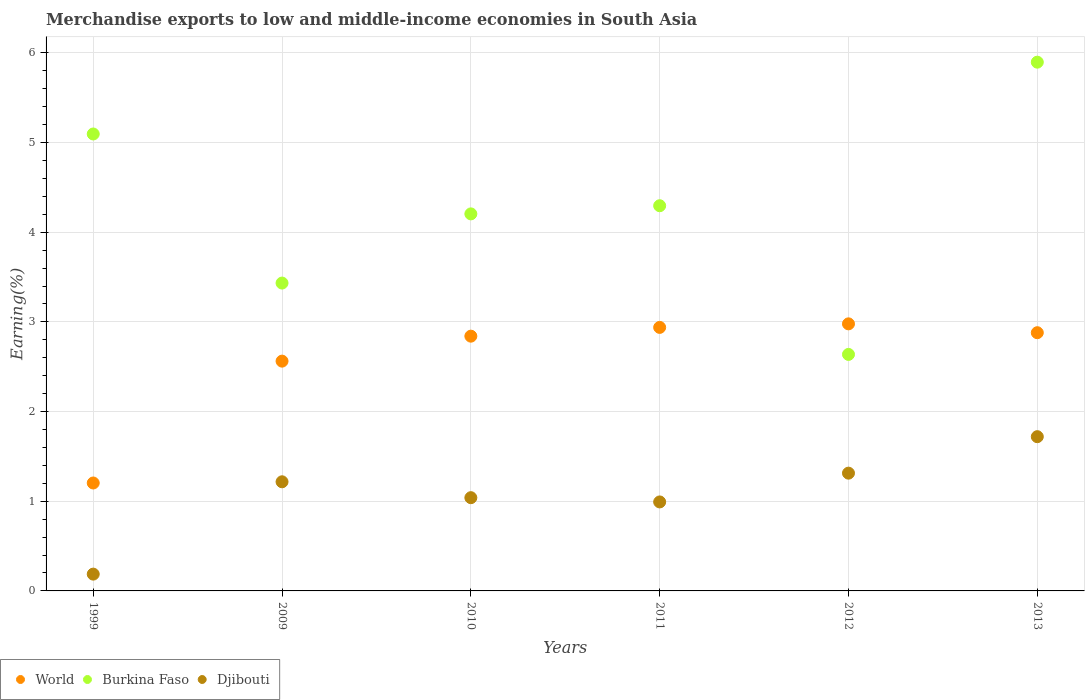How many different coloured dotlines are there?
Offer a very short reply. 3. Is the number of dotlines equal to the number of legend labels?
Give a very brief answer. Yes. What is the percentage of amount earned from merchandise exports in Djibouti in 2011?
Offer a very short reply. 0.99. Across all years, what is the maximum percentage of amount earned from merchandise exports in Burkina Faso?
Make the answer very short. 5.9. Across all years, what is the minimum percentage of amount earned from merchandise exports in World?
Offer a terse response. 1.2. What is the total percentage of amount earned from merchandise exports in Burkina Faso in the graph?
Keep it short and to the point. 25.56. What is the difference between the percentage of amount earned from merchandise exports in Burkina Faso in 2010 and that in 2012?
Your response must be concise. 1.57. What is the difference between the percentage of amount earned from merchandise exports in Djibouti in 2010 and the percentage of amount earned from merchandise exports in Burkina Faso in 2012?
Ensure brevity in your answer.  -1.6. What is the average percentage of amount earned from merchandise exports in World per year?
Your response must be concise. 2.57. In the year 2009, what is the difference between the percentage of amount earned from merchandise exports in World and percentage of amount earned from merchandise exports in Burkina Faso?
Your response must be concise. -0.87. What is the ratio of the percentage of amount earned from merchandise exports in World in 2011 to that in 2013?
Make the answer very short. 1.02. Is the percentage of amount earned from merchandise exports in Djibouti in 2011 less than that in 2013?
Your answer should be very brief. Yes. What is the difference between the highest and the second highest percentage of amount earned from merchandise exports in Djibouti?
Your answer should be compact. 0.41. What is the difference between the highest and the lowest percentage of amount earned from merchandise exports in Djibouti?
Offer a very short reply. 1.53. In how many years, is the percentage of amount earned from merchandise exports in Burkina Faso greater than the average percentage of amount earned from merchandise exports in Burkina Faso taken over all years?
Give a very brief answer. 3. Is the sum of the percentage of amount earned from merchandise exports in World in 1999 and 2009 greater than the maximum percentage of amount earned from merchandise exports in Burkina Faso across all years?
Give a very brief answer. No. Is it the case that in every year, the sum of the percentage of amount earned from merchandise exports in Djibouti and percentage of amount earned from merchandise exports in Burkina Faso  is greater than the percentage of amount earned from merchandise exports in World?
Give a very brief answer. Yes. Is the percentage of amount earned from merchandise exports in World strictly greater than the percentage of amount earned from merchandise exports in Burkina Faso over the years?
Your response must be concise. No. How many dotlines are there?
Make the answer very short. 3. How many years are there in the graph?
Your answer should be compact. 6. Are the values on the major ticks of Y-axis written in scientific E-notation?
Offer a very short reply. No. Does the graph contain any zero values?
Make the answer very short. No. Does the graph contain grids?
Keep it short and to the point. Yes. What is the title of the graph?
Your answer should be very brief. Merchandise exports to low and middle-income economies in South Asia. What is the label or title of the X-axis?
Offer a terse response. Years. What is the label or title of the Y-axis?
Your response must be concise. Earning(%). What is the Earning(%) of World in 1999?
Give a very brief answer. 1.2. What is the Earning(%) of Burkina Faso in 1999?
Your answer should be compact. 5.1. What is the Earning(%) of Djibouti in 1999?
Offer a terse response. 0.19. What is the Earning(%) in World in 2009?
Ensure brevity in your answer.  2.56. What is the Earning(%) in Burkina Faso in 2009?
Ensure brevity in your answer.  3.43. What is the Earning(%) in Djibouti in 2009?
Ensure brevity in your answer.  1.22. What is the Earning(%) in World in 2010?
Make the answer very short. 2.84. What is the Earning(%) of Burkina Faso in 2010?
Provide a short and direct response. 4.2. What is the Earning(%) in Djibouti in 2010?
Ensure brevity in your answer.  1.04. What is the Earning(%) of World in 2011?
Your response must be concise. 2.94. What is the Earning(%) in Burkina Faso in 2011?
Your response must be concise. 4.3. What is the Earning(%) of Djibouti in 2011?
Offer a very short reply. 0.99. What is the Earning(%) in World in 2012?
Make the answer very short. 2.98. What is the Earning(%) in Burkina Faso in 2012?
Offer a terse response. 2.64. What is the Earning(%) in Djibouti in 2012?
Provide a short and direct response. 1.31. What is the Earning(%) in World in 2013?
Provide a short and direct response. 2.88. What is the Earning(%) in Burkina Faso in 2013?
Give a very brief answer. 5.9. What is the Earning(%) of Djibouti in 2013?
Your response must be concise. 1.72. Across all years, what is the maximum Earning(%) of World?
Make the answer very short. 2.98. Across all years, what is the maximum Earning(%) in Burkina Faso?
Provide a short and direct response. 5.9. Across all years, what is the maximum Earning(%) of Djibouti?
Your response must be concise. 1.72. Across all years, what is the minimum Earning(%) of World?
Ensure brevity in your answer.  1.2. Across all years, what is the minimum Earning(%) of Burkina Faso?
Keep it short and to the point. 2.64. Across all years, what is the minimum Earning(%) in Djibouti?
Provide a short and direct response. 0.19. What is the total Earning(%) in World in the graph?
Ensure brevity in your answer.  15.4. What is the total Earning(%) of Burkina Faso in the graph?
Ensure brevity in your answer.  25.56. What is the total Earning(%) of Djibouti in the graph?
Make the answer very short. 6.47. What is the difference between the Earning(%) of World in 1999 and that in 2009?
Keep it short and to the point. -1.36. What is the difference between the Earning(%) in Burkina Faso in 1999 and that in 2009?
Your answer should be very brief. 1.66. What is the difference between the Earning(%) in Djibouti in 1999 and that in 2009?
Give a very brief answer. -1.03. What is the difference between the Earning(%) in World in 1999 and that in 2010?
Provide a short and direct response. -1.64. What is the difference between the Earning(%) in Burkina Faso in 1999 and that in 2010?
Your answer should be very brief. 0.89. What is the difference between the Earning(%) of Djibouti in 1999 and that in 2010?
Offer a terse response. -0.85. What is the difference between the Earning(%) of World in 1999 and that in 2011?
Provide a succinct answer. -1.74. What is the difference between the Earning(%) of Burkina Faso in 1999 and that in 2011?
Your response must be concise. 0.8. What is the difference between the Earning(%) in Djibouti in 1999 and that in 2011?
Make the answer very short. -0.81. What is the difference between the Earning(%) in World in 1999 and that in 2012?
Offer a terse response. -1.77. What is the difference between the Earning(%) in Burkina Faso in 1999 and that in 2012?
Offer a very short reply. 2.46. What is the difference between the Earning(%) of Djibouti in 1999 and that in 2012?
Provide a succinct answer. -1.13. What is the difference between the Earning(%) in World in 1999 and that in 2013?
Your answer should be compact. -1.68. What is the difference between the Earning(%) in Burkina Faso in 1999 and that in 2013?
Your response must be concise. -0.8. What is the difference between the Earning(%) in Djibouti in 1999 and that in 2013?
Keep it short and to the point. -1.53. What is the difference between the Earning(%) in World in 2009 and that in 2010?
Your answer should be compact. -0.28. What is the difference between the Earning(%) of Burkina Faso in 2009 and that in 2010?
Offer a very short reply. -0.77. What is the difference between the Earning(%) in Djibouti in 2009 and that in 2010?
Your response must be concise. 0.18. What is the difference between the Earning(%) in World in 2009 and that in 2011?
Your answer should be compact. -0.38. What is the difference between the Earning(%) of Burkina Faso in 2009 and that in 2011?
Your answer should be very brief. -0.86. What is the difference between the Earning(%) in Djibouti in 2009 and that in 2011?
Provide a short and direct response. 0.22. What is the difference between the Earning(%) of World in 2009 and that in 2012?
Ensure brevity in your answer.  -0.42. What is the difference between the Earning(%) of Burkina Faso in 2009 and that in 2012?
Provide a short and direct response. 0.8. What is the difference between the Earning(%) in Djibouti in 2009 and that in 2012?
Keep it short and to the point. -0.1. What is the difference between the Earning(%) in World in 2009 and that in 2013?
Make the answer very short. -0.32. What is the difference between the Earning(%) of Burkina Faso in 2009 and that in 2013?
Your answer should be compact. -2.46. What is the difference between the Earning(%) in Djibouti in 2009 and that in 2013?
Make the answer very short. -0.5. What is the difference between the Earning(%) of World in 2010 and that in 2011?
Make the answer very short. -0.1. What is the difference between the Earning(%) in Burkina Faso in 2010 and that in 2011?
Offer a very short reply. -0.09. What is the difference between the Earning(%) of Djibouti in 2010 and that in 2011?
Offer a terse response. 0.05. What is the difference between the Earning(%) in World in 2010 and that in 2012?
Keep it short and to the point. -0.14. What is the difference between the Earning(%) in Burkina Faso in 2010 and that in 2012?
Your response must be concise. 1.57. What is the difference between the Earning(%) of Djibouti in 2010 and that in 2012?
Give a very brief answer. -0.27. What is the difference between the Earning(%) in World in 2010 and that in 2013?
Offer a terse response. -0.04. What is the difference between the Earning(%) in Burkina Faso in 2010 and that in 2013?
Make the answer very short. -1.69. What is the difference between the Earning(%) in Djibouti in 2010 and that in 2013?
Offer a terse response. -0.68. What is the difference between the Earning(%) of World in 2011 and that in 2012?
Make the answer very short. -0.04. What is the difference between the Earning(%) of Burkina Faso in 2011 and that in 2012?
Offer a terse response. 1.66. What is the difference between the Earning(%) in Djibouti in 2011 and that in 2012?
Offer a very short reply. -0.32. What is the difference between the Earning(%) of World in 2011 and that in 2013?
Offer a terse response. 0.06. What is the difference between the Earning(%) in Burkina Faso in 2011 and that in 2013?
Your response must be concise. -1.6. What is the difference between the Earning(%) of Djibouti in 2011 and that in 2013?
Ensure brevity in your answer.  -0.73. What is the difference between the Earning(%) of World in 2012 and that in 2013?
Give a very brief answer. 0.1. What is the difference between the Earning(%) in Burkina Faso in 2012 and that in 2013?
Keep it short and to the point. -3.26. What is the difference between the Earning(%) of Djibouti in 2012 and that in 2013?
Your answer should be compact. -0.41. What is the difference between the Earning(%) of World in 1999 and the Earning(%) of Burkina Faso in 2009?
Make the answer very short. -2.23. What is the difference between the Earning(%) in World in 1999 and the Earning(%) in Djibouti in 2009?
Your answer should be very brief. -0.01. What is the difference between the Earning(%) in Burkina Faso in 1999 and the Earning(%) in Djibouti in 2009?
Give a very brief answer. 3.88. What is the difference between the Earning(%) of World in 1999 and the Earning(%) of Burkina Faso in 2010?
Provide a short and direct response. -3. What is the difference between the Earning(%) of World in 1999 and the Earning(%) of Djibouti in 2010?
Offer a terse response. 0.16. What is the difference between the Earning(%) in Burkina Faso in 1999 and the Earning(%) in Djibouti in 2010?
Offer a terse response. 4.06. What is the difference between the Earning(%) of World in 1999 and the Earning(%) of Burkina Faso in 2011?
Ensure brevity in your answer.  -3.09. What is the difference between the Earning(%) of World in 1999 and the Earning(%) of Djibouti in 2011?
Your answer should be very brief. 0.21. What is the difference between the Earning(%) of Burkina Faso in 1999 and the Earning(%) of Djibouti in 2011?
Make the answer very short. 4.1. What is the difference between the Earning(%) in World in 1999 and the Earning(%) in Burkina Faso in 2012?
Your response must be concise. -1.43. What is the difference between the Earning(%) of World in 1999 and the Earning(%) of Djibouti in 2012?
Your answer should be compact. -0.11. What is the difference between the Earning(%) in Burkina Faso in 1999 and the Earning(%) in Djibouti in 2012?
Make the answer very short. 3.78. What is the difference between the Earning(%) in World in 1999 and the Earning(%) in Burkina Faso in 2013?
Provide a succinct answer. -4.69. What is the difference between the Earning(%) of World in 1999 and the Earning(%) of Djibouti in 2013?
Make the answer very short. -0.52. What is the difference between the Earning(%) in Burkina Faso in 1999 and the Earning(%) in Djibouti in 2013?
Give a very brief answer. 3.38. What is the difference between the Earning(%) of World in 2009 and the Earning(%) of Burkina Faso in 2010?
Provide a short and direct response. -1.64. What is the difference between the Earning(%) of World in 2009 and the Earning(%) of Djibouti in 2010?
Offer a terse response. 1.52. What is the difference between the Earning(%) of Burkina Faso in 2009 and the Earning(%) of Djibouti in 2010?
Offer a terse response. 2.39. What is the difference between the Earning(%) of World in 2009 and the Earning(%) of Burkina Faso in 2011?
Give a very brief answer. -1.73. What is the difference between the Earning(%) of World in 2009 and the Earning(%) of Djibouti in 2011?
Provide a succinct answer. 1.57. What is the difference between the Earning(%) in Burkina Faso in 2009 and the Earning(%) in Djibouti in 2011?
Your answer should be compact. 2.44. What is the difference between the Earning(%) in World in 2009 and the Earning(%) in Burkina Faso in 2012?
Your answer should be compact. -0.07. What is the difference between the Earning(%) of World in 2009 and the Earning(%) of Djibouti in 2012?
Keep it short and to the point. 1.25. What is the difference between the Earning(%) of Burkina Faso in 2009 and the Earning(%) of Djibouti in 2012?
Your response must be concise. 2.12. What is the difference between the Earning(%) in World in 2009 and the Earning(%) in Burkina Faso in 2013?
Offer a very short reply. -3.33. What is the difference between the Earning(%) in World in 2009 and the Earning(%) in Djibouti in 2013?
Make the answer very short. 0.84. What is the difference between the Earning(%) in Burkina Faso in 2009 and the Earning(%) in Djibouti in 2013?
Your response must be concise. 1.71. What is the difference between the Earning(%) of World in 2010 and the Earning(%) of Burkina Faso in 2011?
Keep it short and to the point. -1.45. What is the difference between the Earning(%) of World in 2010 and the Earning(%) of Djibouti in 2011?
Give a very brief answer. 1.85. What is the difference between the Earning(%) of Burkina Faso in 2010 and the Earning(%) of Djibouti in 2011?
Your answer should be very brief. 3.21. What is the difference between the Earning(%) of World in 2010 and the Earning(%) of Burkina Faso in 2012?
Your answer should be very brief. 0.2. What is the difference between the Earning(%) of World in 2010 and the Earning(%) of Djibouti in 2012?
Your answer should be very brief. 1.53. What is the difference between the Earning(%) of Burkina Faso in 2010 and the Earning(%) of Djibouti in 2012?
Give a very brief answer. 2.89. What is the difference between the Earning(%) in World in 2010 and the Earning(%) in Burkina Faso in 2013?
Your response must be concise. -3.06. What is the difference between the Earning(%) of World in 2010 and the Earning(%) of Djibouti in 2013?
Make the answer very short. 1.12. What is the difference between the Earning(%) of Burkina Faso in 2010 and the Earning(%) of Djibouti in 2013?
Your answer should be very brief. 2.48. What is the difference between the Earning(%) of World in 2011 and the Earning(%) of Burkina Faso in 2012?
Your answer should be very brief. 0.3. What is the difference between the Earning(%) of World in 2011 and the Earning(%) of Djibouti in 2012?
Your answer should be compact. 1.63. What is the difference between the Earning(%) of Burkina Faso in 2011 and the Earning(%) of Djibouti in 2012?
Provide a succinct answer. 2.98. What is the difference between the Earning(%) of World in 2011 and the Earning(%) of Burkina Faso in 2013?
Make the answer very short. -2.96. What is the difference between the Earning(%) in World in 2011 and the Earning(%) in Djibouti in 2013?
Provide a succinct answer. 1.22. What is the difference between the Earning(%) of Burkina Faso in 2011 and the Earning(%) of Djibouti in 2013?
Make the answer very short. 2.58. What is the difference between the Earning(%) of World in 2012 and the Earning(%) of Burkina Faso in 2013?
Make the answer very short. -2.92. What is the difference between the Earning(%) in World in 2012 and the Earning(%) in Djibouti in 2013?
Make the answer very short. 1.26. What is the difference between the Earning(%) of Burkina Faso in 2012 and the Earning(%) of Djibouti in 2013?
Make the answer very short. 0.92. What is the average Earning(%) in World per year?
Your answer should be very brief. 2.57. What is the average Earning(%) in Burkina Faso per year?
Make the answer very short. 4.26. What is the average Earning(%) of Djibouti per year?
Offer a terse response. 1.08. In the year 1999, what is the difference between the Earning(%) in World and Earning(%) in Burkina Faso?
Offer a very short reply. -3.89. In the year 1999, what is the difference between the Earning(%) in World and Earning(%) in Djibouti?
Your answer should be very brief. 1.02. In the year 1999, what is the difference between the Earning(%) of Burkina Faso and Earning(%) of Djibouti?
Offer a terse response. 4.91. In the year 2009, what is the difference between the Earning(%) of World and Earning(%) of Burkina Faso?
Your answer should be compact. -0.87. In the year 2009, what is the difference between the Earning(%) of World and Earning(%) of Djibouti?
Give a very brief answer. 1.35. In the year 2009, what is the difference between the Earning(%) in Burkina Faso and Earning(%) in Djibouti?
Ensure brevity in your answer.  2.22. In the year 2010, what is the difference between the Earning(%) in World and Earning(%) in Burkina Faso?
Offer a very short reply. -1.36. In the year 2010, what is the difference between the Earning(%) of World and Earning(%) of Djibouti?
Your answer should be compact. 1.8. In the year 2010, what is the difference between the Earning(%) of Burkina Faso and Earning(%) of Djibouti?
Make the answer very short. 3.16. In the year 2011, what is the difference between the Earning(%) in World and Earning(%) in Burkina Faso?
Offer a terse response. -1.36. In the year 2011, what is the difference between the Earning(%) of World and Earning(%) of Djibouti?
Provide a succinct answer. 1.95. In the year 2011, what is the difference between the Earning(%) in Burkina Faso and Earning(%) in Djibouti?
Provide a short and direct response. 3.3. In the year 2012, what is the difference between the Earning(%) of World and Earning(%) of Burkina Faso?
Your response must be concise. 0.34. In the year 2012, what is the difference between the Earning(%) in World and Earning(%) in Djibouti?
Offer a very short reply. 1.67. In the year 2012, what is the difference between the Earning(%) in Burkina Faso and Earning(%) in Djibouti?
Provide a short and direct response. 1.32. In the year 2013, what is the difference between the Earning(%) in World and Earning(%) in Burkina Faso?
Your response must be concise. -3.02. In the year 2013, what is the difference between the Earning(%) in World and Earning(%) in Djibouti?
Keep it short and to the point. 1.16. In the year 2013, what is the difference between the Earning(%) in Burkina Faso and Earning(%) in Djibouti?
Keep it short and to the point. 4.18. What is the ratio of the Earning(%) of World in 1999 to that in 2009?
Your answer should be very brief. 0.47. What is the ratio of the Earning(%) in Burkina Faso in 1999 to that in 2009?
Make the answer very short. 1.48. What is the ratio of the Earning(%) in Djibouti in 1999 to that in 2009?
Your answer should be compact. 0.15. What is the ratio of the Earning(%) in World in 1999 to that in 2010?
Offer a terse response. 0.42. What is the ratio of the Earning(%) in Burkina Faso in 1999 to that in 2010?
Keep it short and to the point. 1.21. What is the ratio of the Earning(%) of Djibouti in 1999 to that in 2010?
Your answer should be compact. 0.18. What is the ratio of the Earning(%) in World in 1999 to that in 2011?
Give a very brief answer. 0.41. What is the ratio of the Earning(%) in Burkina Faso in 1999 to that in 2011?
Ensure brevity in your answer.  1.19. What is the ratio of the Earning(%) in Djibouti in 1999 to that in 2011?
Ensure brevity in your answer.  0.19. What is the ratio of the Earning(%) in World in 1999 to that in 2012?
Your response must be concise. 0.4. What is the ratio of the Earning(%) in Burkina Faso in 1999 to that in 2012?
Ensure brevity in your answer.  1.93. What is the ratio of the Earning(%) in Djibouti in 1999 to that in 2012?
Offer a very short reply. 0.14. What is the ratio of the Earning(%) of World in 1999 to that in 2013?
Your answer should be compact. 0.42. What is the ratio of the Earning(%) of Burkina Faso in 1999 to that in 2013?
Offer a very short reply. 0.86. What is the ratio of the Earning(%) in Djibouti in 1999 to that in 2013?
Ensure brevity in your answer.  0.11. What is the ratio of the Earning(%) in World in 2009 to that in 2010?
Provide a succinct answer. 0.9. What is the ratio of the Earning(%) of Burkina Faso in 2009 to that in 2010?
Your answer should be compact. 0.82. What is the ratio of the Earning(%) of Djibouti in 2009 to that in 2010?
Make the answer very short. 1.17. What is the ratio of the Earning(%) of World in 2009 to that in 2011?
Keep it short and to the point. 0.87. What is the ratio of the Earning(%) in Burkina Faso in 2009 to that in 2011?
Your answer should be compact. 0.8. What is the ratio of the Earning(%) in Djibouti in 2009 to that in 2011?
Keep it short and to the point. 1.23. What is the ratio of the Earning(%) in World in 2009 to that in 2012?
Provide a succinct answer. 0.86. What is the ratio of the Earning(%) of Burkina Faso in 2009 to that in 2012?
Provide a short and direct response. 1.3. What is the ratio of the Earning(%) in Djibouti in 2009 to that in 2012?
Offer a terse response. 0.93. What is the ratio of the Earning(%) of World in 2009 to that in 2013?
Make the answer very short. 0.89. What is the ratio of the Earning(%) in Burkina Faso in 2009 to that in 2013?
Your response must be concise. 0.58. What is the ratio of the Earning(%) in Djibouti in 2009 to that in 2013?
Provide a succinct answer. 0.71. What is the ratio of the Earning(%) of World in 2010 to that in 2011?
Your response must be concise. 0.97. What is the ratio of the Earning(%) in Burkina Faso in 2010 to that in 2011?
Provide a short and direct response. 0.98. What is the ratio of the Earning(%) of Djibouti in 2010 to that in 2011?
Your answer should be very brief. 1.05. What is the ratio of the Earning(%) in World in 2010 to that in 2012?
Provide a short and direct response. 0.95. What is the ratio of the Earning(%) in Burkina Faso in 2010 to that in 2012?
Provide a short and direct response. 1.59. What is the ratio of the Earning(%) of Djibouti in 2010 to that in 2012?
Make the answer very short. 0.79. What is the ratio of the Earning(%) of World in 2010 to that in 2013?
Offer a terse response. 0.99. What is the ratio of the Earning(%) in Burkina Faso in 2010 to that in 2013?
Offer a very short reply. 0.71. What is the ratio of the Earning(%) in Djibouti in 2010 to that in 2013?
Ensure brevity in your answer.  0.6. What is the ratio of the Earning(%) in World in 2011 to that in 2012?
Offer a very short reply. 0.99. What is the ratio of the Earning(%) of Burkina Faso in 2011 to that in 2012?
Ensure brevity in your answer.  1.63. What is the ratio of the Earning(%) in Djibouti in 2011 to that in 2012?
Offer a very short reply. 0.76. What is the ratio of the Earning(%) in World in 2011 to that in 2013?
Provide a short and direct response. 1.02. What is the ratio of the Earning(%) in Burkina Faso in 2011 to that in 2013?
Ensure brevity in your answer.  0.73. What is the ratio of the Earning(%) of Djibouti in 2011 to that in 2013?
Ensure brevity in your answer.  0.58. What is the ratio of the Earning(%) in World in 2012 to that in 2013?
Your response must be concise. 1.03. What is the ratio of the Earning(%) in Burkina Faso in 2012 to that in 2013?
Offer a very short reply. 0.45. What is the ratio of the Earning(%) of Djibouti in 2012 to that in 2013?
Provide a short and direct response. 0.76. What is the difference between the highest and the second highest Earning(%) in World?
Provide a short and direct response. 0.04. What is the difference between the highest and the second highest Earning(%) of Burkina Faso?
Your response must be concise. 0.8. What is the difference between the highest and the second highest Earning(%) in Djibouti?
Give a very brief answer. 0.41. What is the difference between the highest and the lowest Earning(%) in World?
Your response must be concise. 1.77. What is the difference between the highest and the lowest Earning(%) in Burkina Faso?
Your response must be concise. 3.26. What is the difference between the highest and the lowest Earning(%) of Djibouti?
Make the answer very short. 1.53. 